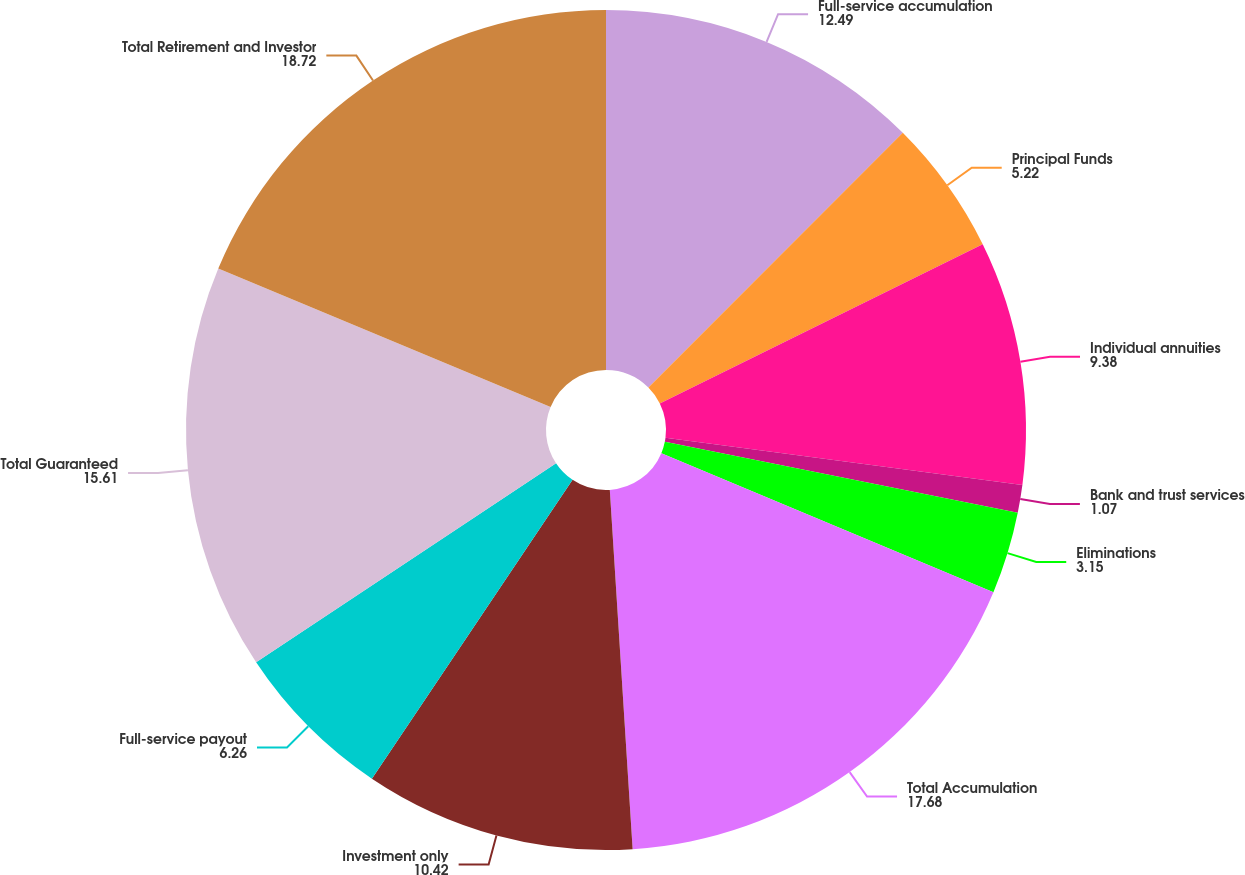<chart> <loc_0><loc_0><loc_500><loc_500><pie_chart><fcel>Full-service accumulation<fcel>Principal Funds<fcel>Individual annuities<fcel>Bank and trust services<fcel>Eliminations<fcel>Total Accumulation<fcel>Investment only<fcel>Full-service payout<fcel>Total Guaranteed<fcel>Total Retirement and Investor<nl><fcel>12.49%<fcel>5.22%<fcel>9.38%<fcel>1.07%<fcel>3.15%<fcel>17.68%<fcel>10.42%<fcel>6.26%<fcel>15.61%<fcel>18.72%<nl></chart> 